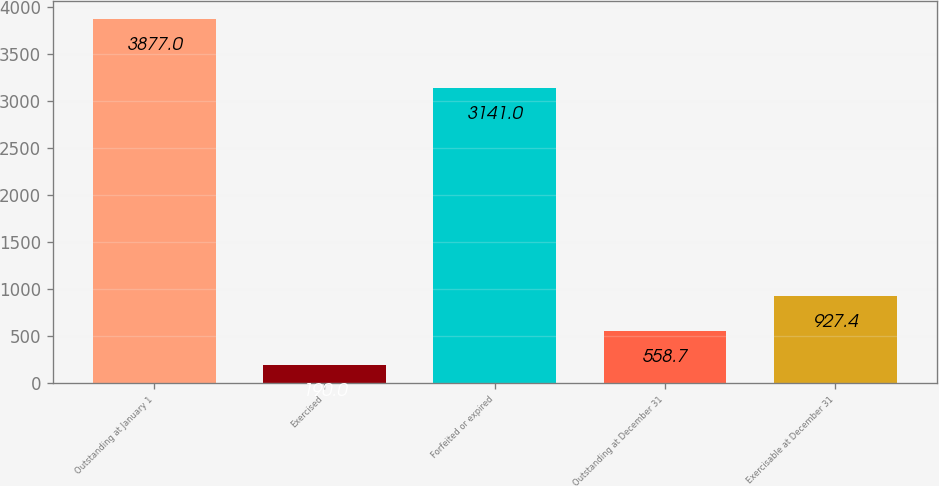Convert chart. <chart><loc_0><loc_0><loc_500><loc_500><bar_chart><fcel>Outstanding at January 1<fcel>Exercised<fcel>Forfeited or expired<fcel>Outstanding at December 31<fcel>Exercisable at December 31<nl><fcel>3877<fcel>190<fcel>3141<fcel>558.7<fcel>927.4<nl></chart> 